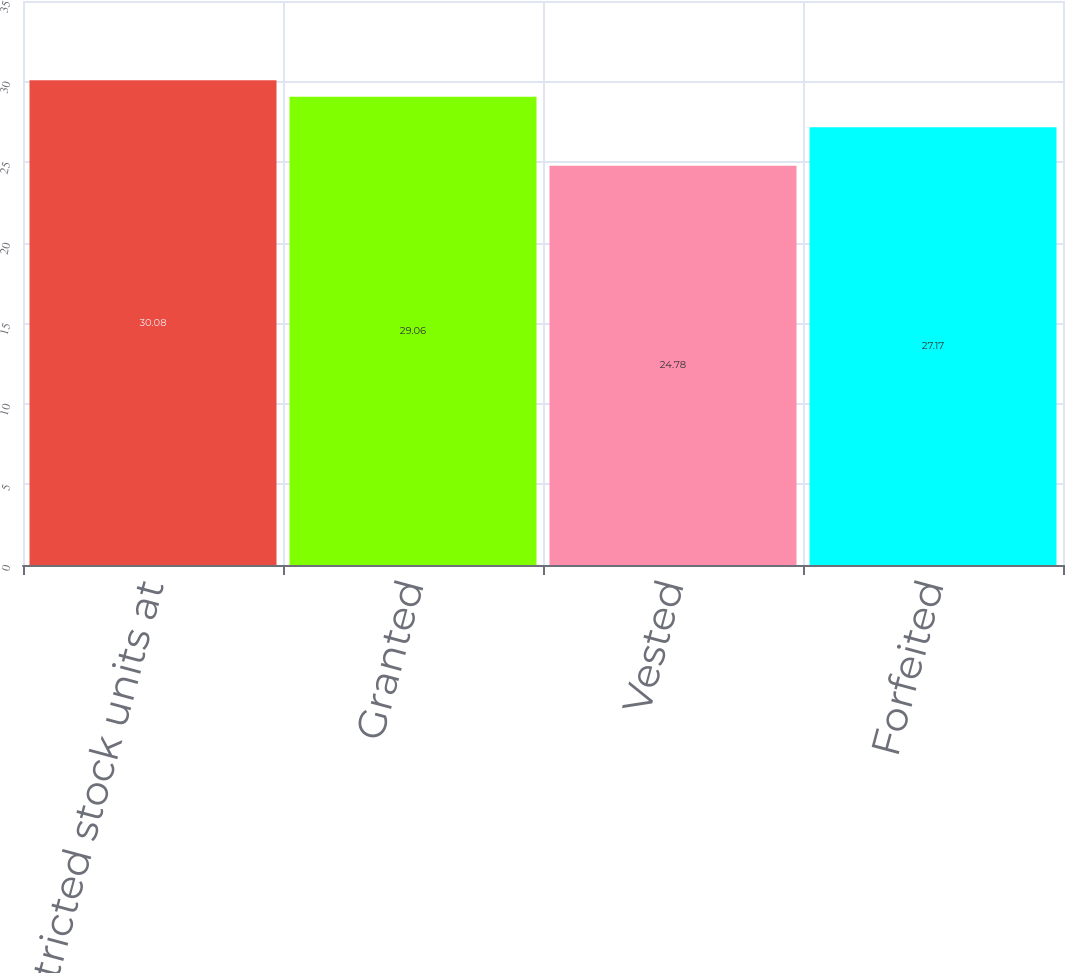Convert chart to OTSL. <chart><loc_0><loc_0><loc_500><loc_500><bar_chart><fcel>Restricted stock units at<fcel>Granted<fcel>Vested<fcel>Forfeited<nl><fcel>30.08<fcel>29.06<fcel>24.78<fcel>27.17<nl></chart> 